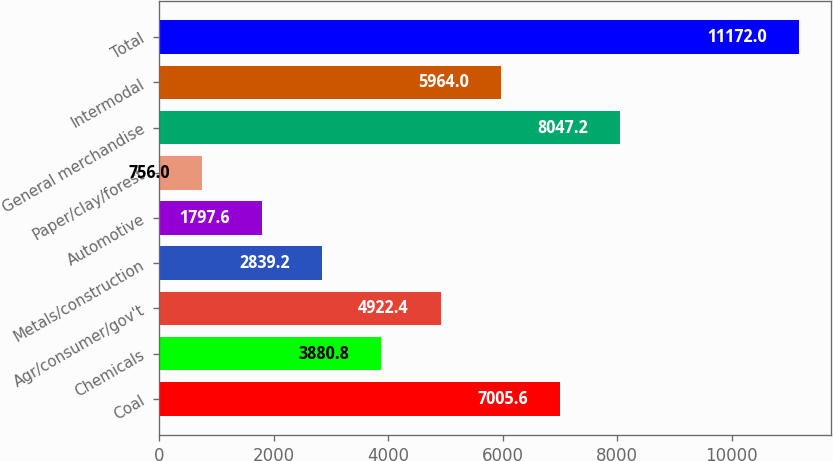Convert chart to OTSL. <chart><loc_0><loc_0><loc_500><loc_500><bar_chart><fcel>Coal<fcel>Chemicals<fcel>Agr/consumer/gov't<fcel>Metals/construction<fcel>Automotive<fcel>Paper/clay/forest<fcel>General merchandise<fcel>Intermodal<fcel>Total<nl><fcel>7005.6<fcel>3880.8<fcel>4922.4<fcel>2839.2<fcel>1797.6<fcel>756<fcel>8047.2<fcel>5964<fcel>11172<nl></chart> 